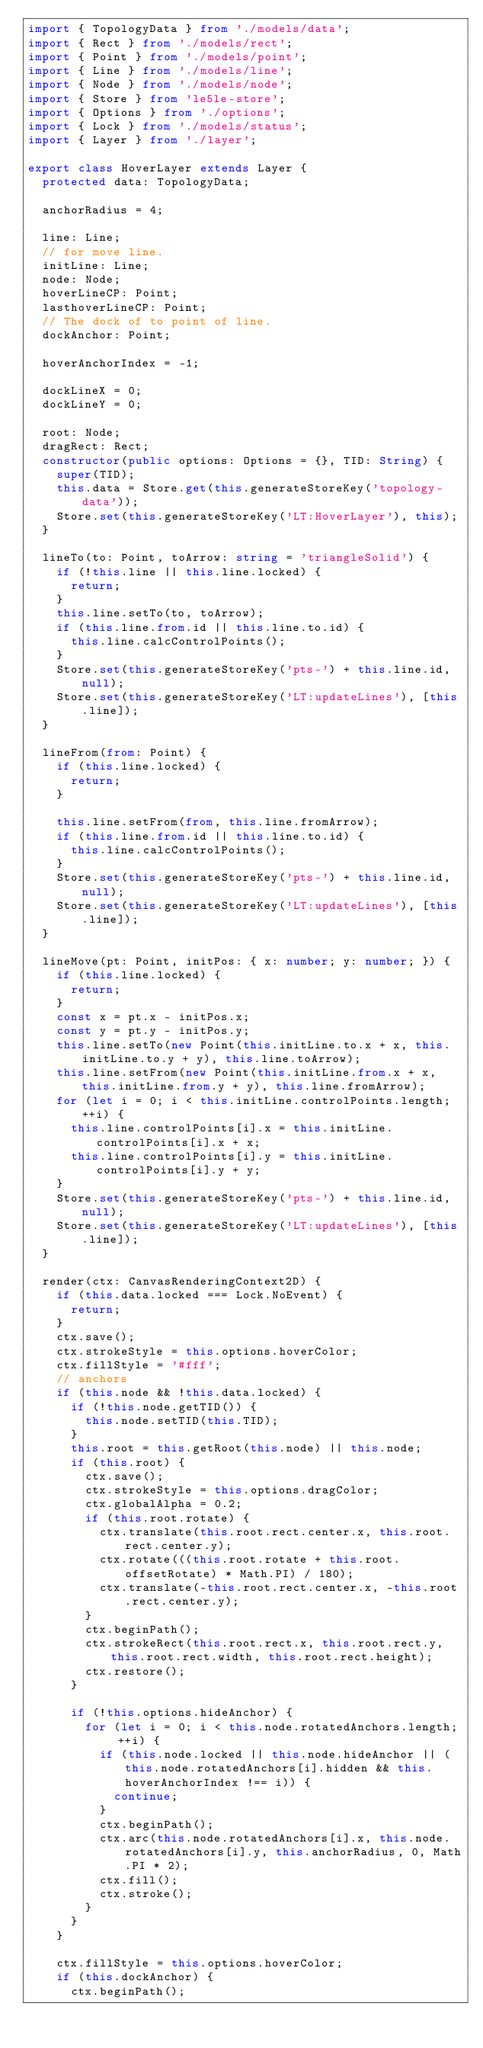<code> <loc_0><loc_0><loc_500><loc_500><_TypeScript_>import { TopologyData } from './models/data';
import { Rect } from './models/rect';
import { Point } from './models/point';
import { Line } from './models/line';
import { Node } from './models/node';
import { Store } from 'le5le-store';
import { Options } from './options';
import { Lock } from './models/status';
import { Layer } from './layer';

export class HoverLayer extends Layer {
  protected data: TopologyData;

  anchorRadius = 4;

  line: Line;
  // for move line.
  initLine: Line;
  node: Node;
  hoverLineCP: Point;
  lasthoverLineCP: Point;
  // The dock of to point of line.
  dockAnchor: Point;

  hoverAnchorIndex = -1;

  dockLineX = 0;
  dockLineY = 0;

  root: Node;
  dragRect: Rect;
  constructor(public options: Options = {}, TID: String) {
    super(TID);
    this.data = Store.get(this.generateStoreKey('topology-data'));
    Store.set(this.generateStoreKey('LT:HoverLayer'), this);
  }

  lineTo(to: Point, toArrow: string = 'triangleSolid') {
    if (!this.line || this.line.locked) {
      return;
    }
    this.line.setTo(to, toArrow);
    if (this.line.from.id || this.line.to.id) {
      this.line.calcControlPoints();
    }
    Store.set(this.generateStoreKey('pts-') + this.line.id, null);
    Store.set(this.generateStoreKey('LT:updateLines'), [this.line]);
  }

  lineFrom(from: Point) {
    if (this.line.locked) {
      return;
    }

    this.line.setFrom(from, this.line.fromArrow);
    if (this.line.from.id || this.line.to.id) {
      this.line.calcControlPoints();
    }
    Store.set(this.generateStoreKey('pts-') + this.line.id, null);
    Store.set(this.generateStoreKey('LT:updateLines'), [this.line]);
  }

  lineMove(pt: Point, initPos: { x: number; y: number; }) {
    if (this.line.locked) {
      return;
    }
    const x = pt.x - initPos.x;
    const y = pt.y - initPos.y;
    this.line.setTo(new Point(this.initLine.to.x + x, this.initLine.to.y + y), this.line.toArrow);
    this.line.setFrom(new Point(this.initLine.from.x + x, this.initLine.from.y + y), this.line.fromArrow);
    for (let i = 0; i < this.initLine.controlPoints.length; ++i) {
      this.line.controlPoints[i].x = this.initLine.controlPoints[i].x + x;
      this.line.controlPoints[i].y = this.initLine.controlPoints[i].y + y;
    }
    Store.set(this.generateStoreKey('pts-') + this.line.id, null);
    Store.set(this.generateStoreKey('LT:updateLines'), [this.line]);
  }

  render(ctx: CanvasRenderingContext2D) {
    if (this.data.locked === Lock.NoEvent) {
      return;
    }
    ctx.save();
    ctx.strokeStyle = this.options.hoverColor;
    ctx.fillStyle = '#fff';
    // anchors
    if (this.node && !this.data.locked) {
      if (!this.node.getTID()) {
        this.node.setTID(this.TID);
      }
      this.root = this.getRoot(this.node) || this.node;
      if (this.root) {
        ctx.save();
        ctx.strokeStyle = this.options.dragColor;
        ctx.globalAlpha = 0.2;
        if (this.root.rotate) {
          ctx.translate(this.root.rect.center.x, this.root.rect.center.y);
          ctx.rotate(((this.root.rotate + this.root.offsetRotate) * Math.PI) / 180);
          ctx.translate(-this.root.rect.center.x, -this.root.rect.center.y);
        }
        ctx.beginPath();
        ctx.strokeRect(this.root.rect.x, this.root.rect.y, this.root.rect.width, this.root.rect.height);
        ctx.restore();
      }

      if (!this.options.hideAnchor) {
        for (let i = 0; i < this.node.rotatedAnchors.length; ++i) {
          if (this.node.locked || this.node.hideAnchor || (this.node.rotatedAnchors[i].hidden && this.hoverAnchorIndex !== i)) {
            continue;
          }
          ctx.beginPath();
          ctx.arc(this.node.rotatedAnchors[i].x, this.node.rotatedAnchors[i].y, this.anchorRadius, 0, Math.PI * 2);
          ctx.fill();
          ctx.stroke();
        }
      }
    }

    ctx.fillStyle = this.options.hoverColor;
    if (this.dockAnchor) {
      ctx.beginPath();</code> 